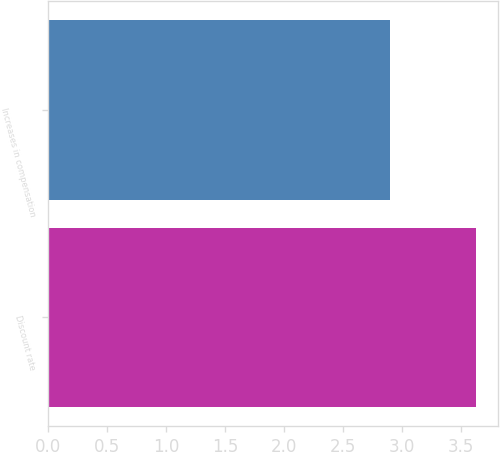<chart> <loc_0><loc_0><loc_500><loc_500><bar_chart><fcel>Discount rate<fcel>Increases in compensation<nl><fcel>3.63<fcel>2.9<nl></chart> 